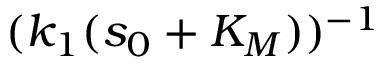Convert formula to latex. <formula><loc_0><loc_0><loc_500><loc_500>( k _ { 1 } ( s _ { 0 } + K _ { M } ) ) ^ { - 1 }</formula> 